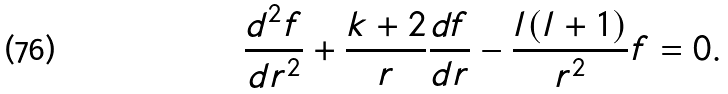Convert formula to latex. <formula><loc_0><loc_0><loc_500><loc_500>\frac { d ^ { 2 } f } { d r ^ { 2 } } + \frac { k + 2 } { r } \frac { d f } { d r } - \frac { l ( l + 1 ) } { r ^ { 2 } } f = 0 .</formula> 